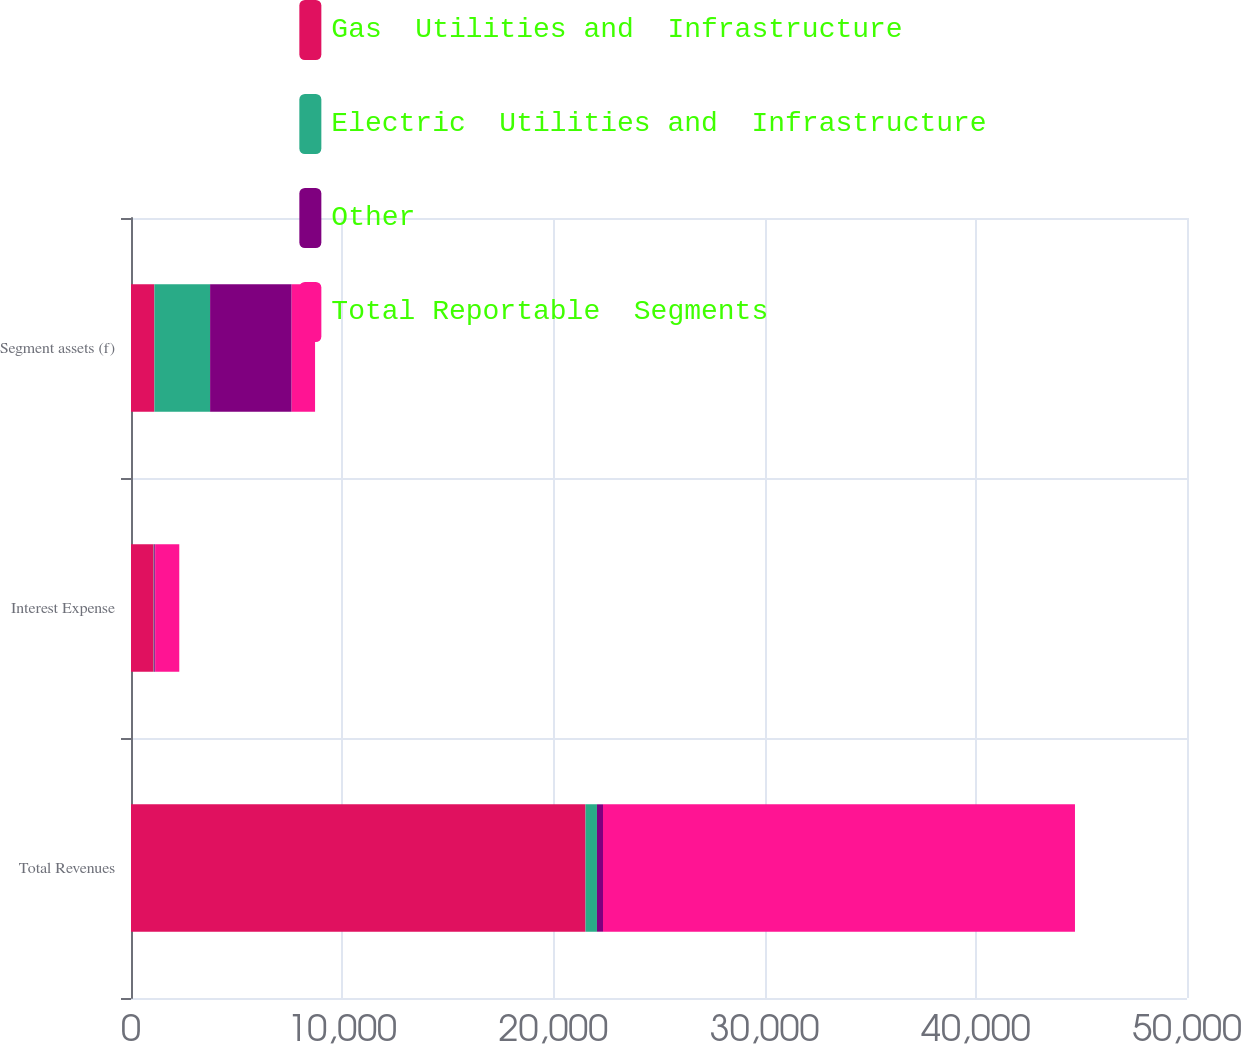Convert chart to OTSL. <chart><loc_0><loc_0><loc_500><loc_500><stacked_bar_chart><ecel><fcel>Total Revenues<fcel>Interest Expense<fcel>Segment assets (f)<nl><fcel>Gas  Utilities and  Infrastructure<fcel>21521<fcel>1074<fcel>1108.5<nl><fcel>Electric  Utilities and  Infrastructure<fcel>541<fcel>25<fcel>2637<nl><fcel>Other<fcel>286<fcel>44<fcel>3861<nl><fcel>Total Reportable  Segments<fcel>22348<fcel>1143<fcel>1108.5<nl></chart> 